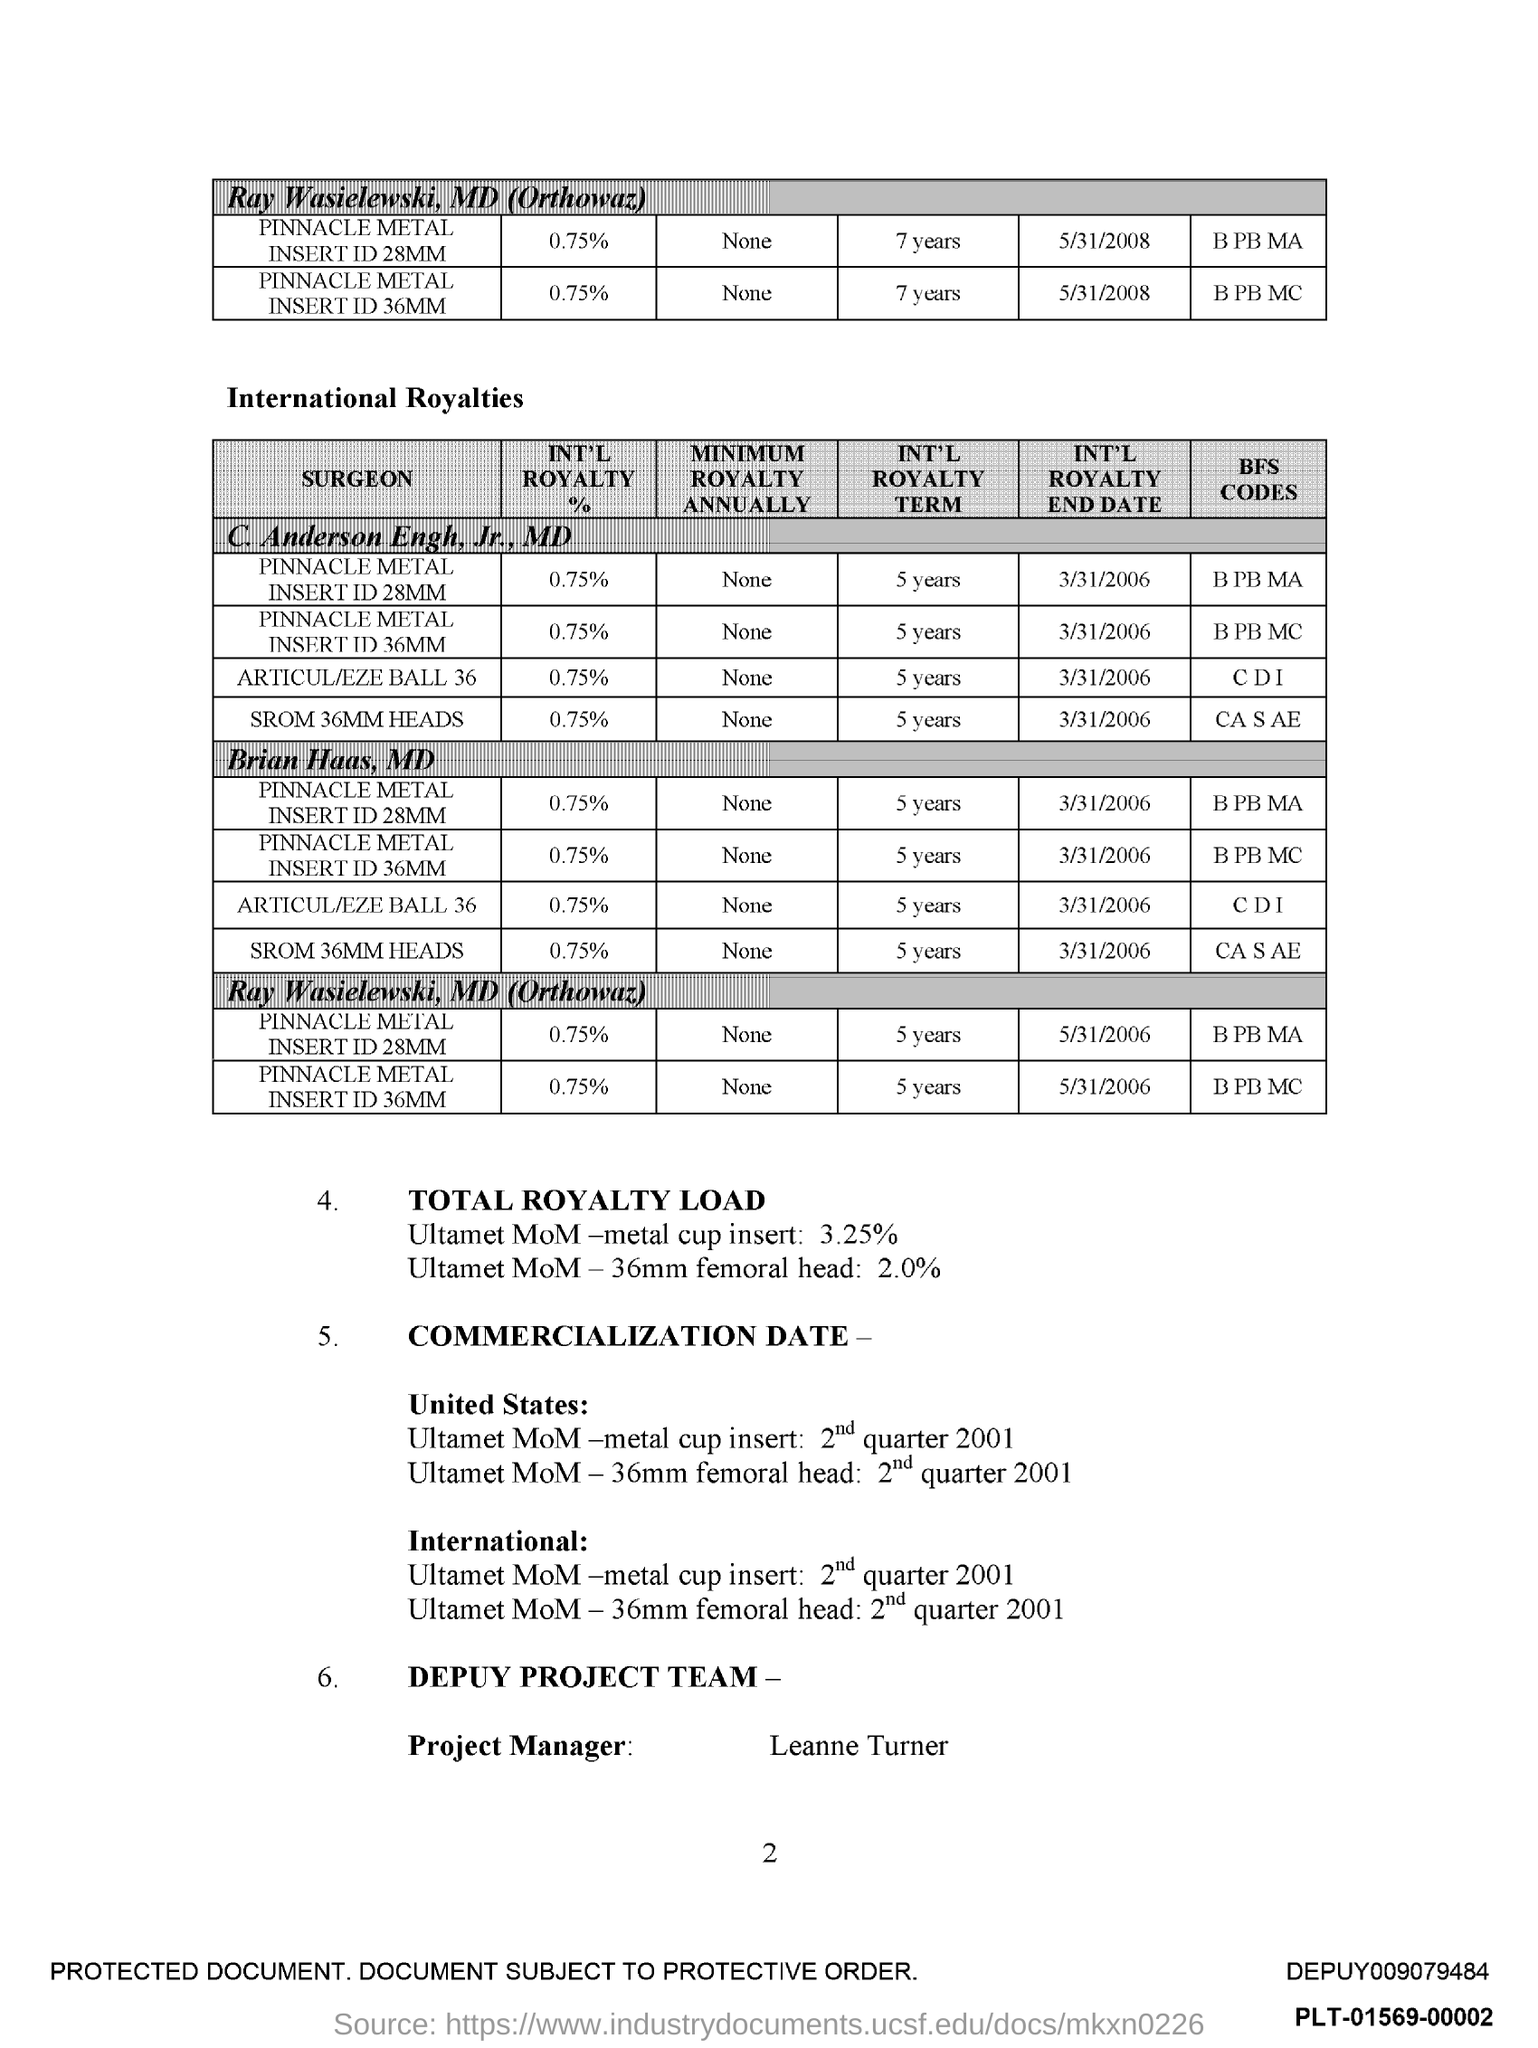What is the name of Project Manager?
Your response must be concise. Leanne Turner. 